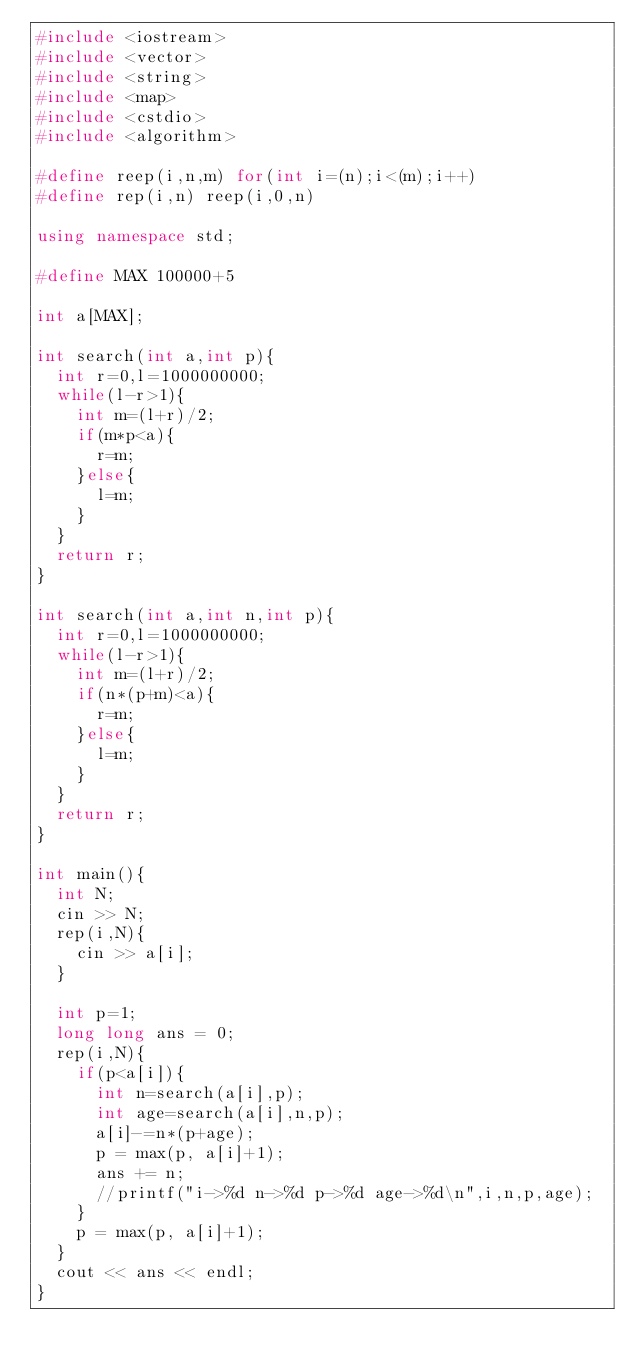Convert code to text. <code><loc_0><loc_0><loc_500><loc_500><_C++_>#include <iostream>
#include <vector>
#include <string>
#include <map>
#include <cstdio>
#include <algorithm>

#define reep(i,n,m) for(int i=(n);i<(m);i++)
#define rep(i,n) reep(i,0,n)

using namespace std;

#define MAX 100000+5

int a[MAX];

int search(int a,int p){
	int r=0,l=1000000000;
	while(l-r>1){
		int m=(l+r)/2;
		if(m*p<a){
			r=m;
		}else{
			l=m;
		}
	}
	return r;
}

int search(int a,int n,int p){
	int r=0,l=1000000000;
	while(l-r>1){
		int m=(l+r)/2;
		if(n*(p+m)<a){
			r=m;
		}else{
			l=m;
		}
	}
	return r;
}

int main(){
	int N;
	cin >> N;
	rep(i,N){
		cin >> a[i];
	}

	int p=1;
	long long ans = 0;
	rep(i,N){
		if(p<a[i]){
			int n=search(a[i],p);
			int age=search(a[i],n,p);
			a[i]-=n*(p+age);
			p = max(p, a[i]+1);
			ans += n;
			//printf("i->%d n->%d p->%d age->%d\n",i,n,p,age);
		}
		p = max(p, a[i]+1);
	}
	cout << ans << endl;
}</code> 